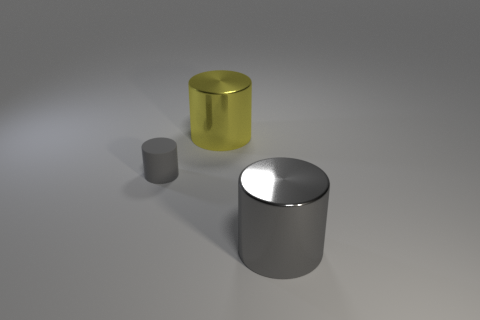Is there a cylinder of the same size as the gray rubber object?
Provide a short and direct response. No. How many metal things are either large red cylinders or small cylinders?
Offer a terse response. 0. The big thing that is the same color as the rubber cylinder is what shape?
Your answer should be compact. Cylinder. What number of gray metal objects are there?
Your answer should be very brief. 1. Does the gray object that is right of the small gray matte thing have the same material as the large cylinder behind the big gray cylinder?
Your answer should be very brief. Yes. The gray thing that is made of the same material as the yellow cylinder is what size?
Offer a very short reply. Large. There is a big metal object on the left side of the gray metal cylinder; what shape is it?
Provide a short and direct response. Cylinder. Is the color of the large metallic cylinder that is on the right side of the big yellow shiny thing the same as the object to the left of the yellow metal object?
Keep it short and to the point. Yes. The thing that is the same color as the tiny cylinder is what size?
Keep it short and to the point. Large. Are there any small metallic blocks?
Offer a terse response. No. 